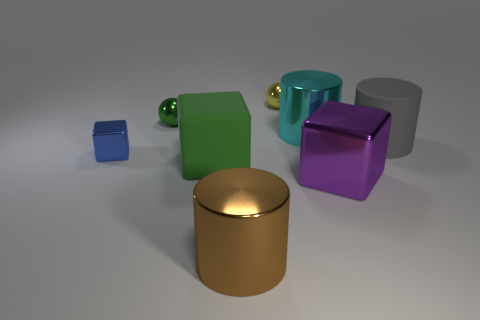Does the shiny sphere that is in front of the yellow object have the same color as the big rubber object that is in front of the big rubber cylinder?
Offer a terse response. Yes. Is the shape of the green object behind the gray matte object the same as the matte object in front of the large gray cylinder?
Keep it short and to the point. No. How many objects are either tiny things in front of the cyan metal cylinder or blue shiny spheres?
Your answer should be compact. 1. Are there any small yellow shiny spheres that are behind the big metallic cylinder in front of the shiny block right of the brown metallic thing?
Provide a short and direct response. Yes. Are there fewer metal cylinders right of the large gray thing than tiny shiny spheres that are behind the green sphere?
Keep it short and to the point. Yes. The other cube that is made of the same material as the tiny block is what color?
Make the answer very short. Purple. What color is the small metallic ball on the right side of the large rubber thing to the left of the small yellow sphere?
Give a very brief answer. Yellow. Are there any metal spheres that have the same color as the rubber block?
Your answer should be very brief. Yes. The brown object that is the same size as the cyan cylinder is what shape?
Your answer should be compact. Cylinder. There is a big metal cylinder in front of the large purple block; how many large green rubber things are to the left of it?
Provide a succinct answer. 1. 